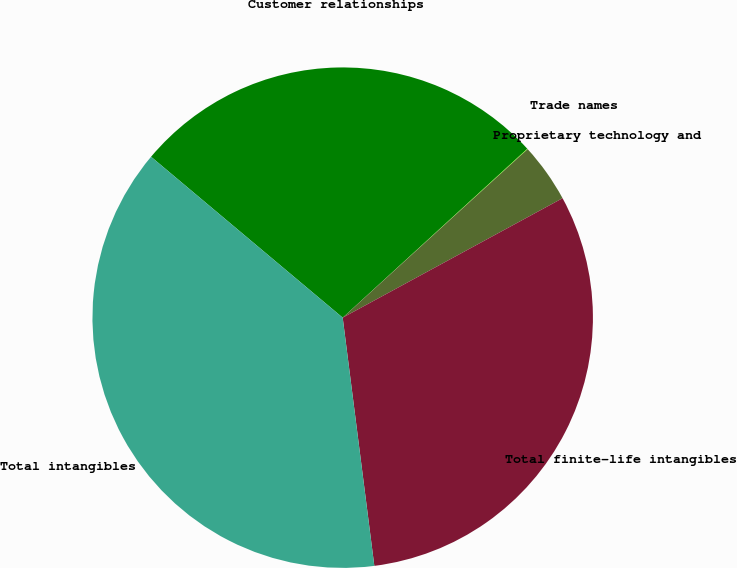<chart> <loc_0><loc_0><loc_500><loc_500><pie_chart><fcel>Customer relationships<fcel>Trade names<fcel>Proprietary technology and<fcel>Total finite-life intangibles<fcel>Total intangibles<nl><fcel>27.09%<fcel>0.03%<fcel>3.84%<fcel>30.9%<fcel>38.13%<nl></chart> 